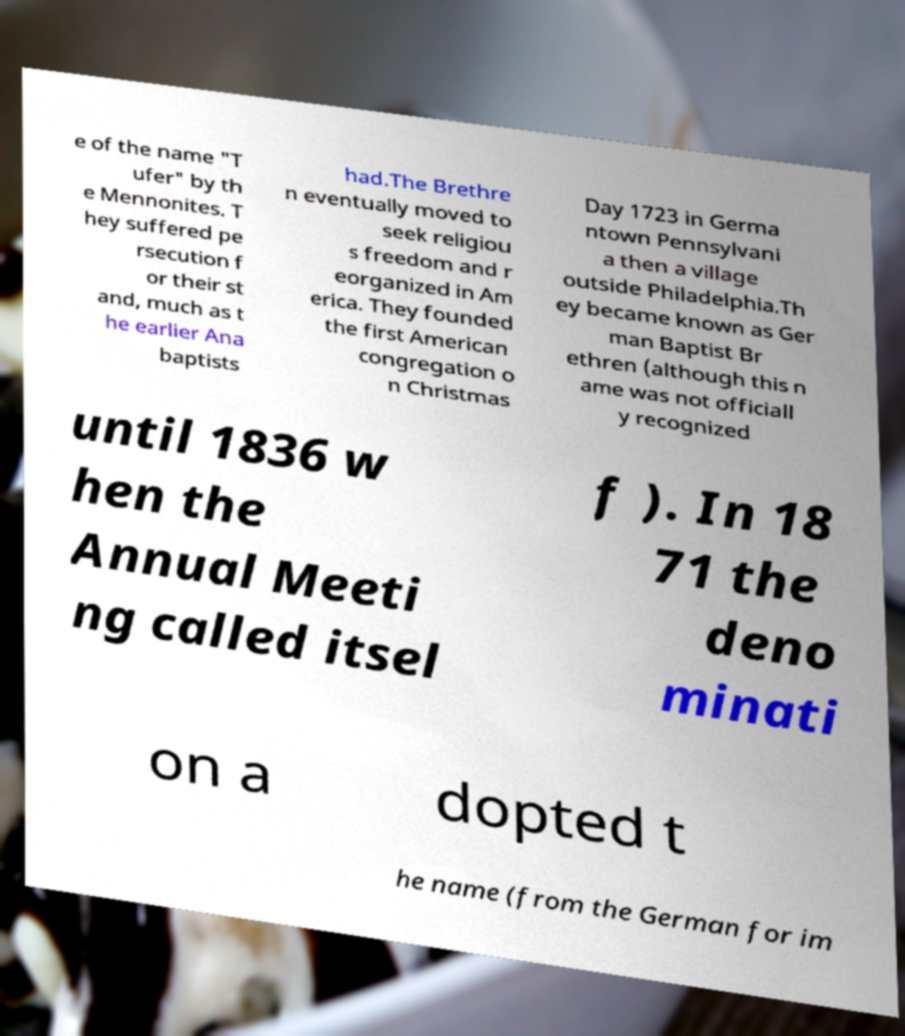For documentation purposes, I need the text within this image transcribed. Could you provide that? e of the name "T ufer" by th e Mennonites. T hey suffered pe rsecution f or their st and, much as t he earlier Ana baptists had.The Brethre n eventually moved to seek religiou s freedom and r eorganized in Am erica. They founded the first American congregation o n Christmas Day 1723 in Germa ntown Pennsylvani a then a village outside Philadelphia.Th ey became known as Ger man Baptist Br ethren (although this n ame was not officiall y recognized until 1836 w hen the Annual Meeti ng called itsel f ). In 18 71 the deno minati on a dopted t he name (from the German for im 